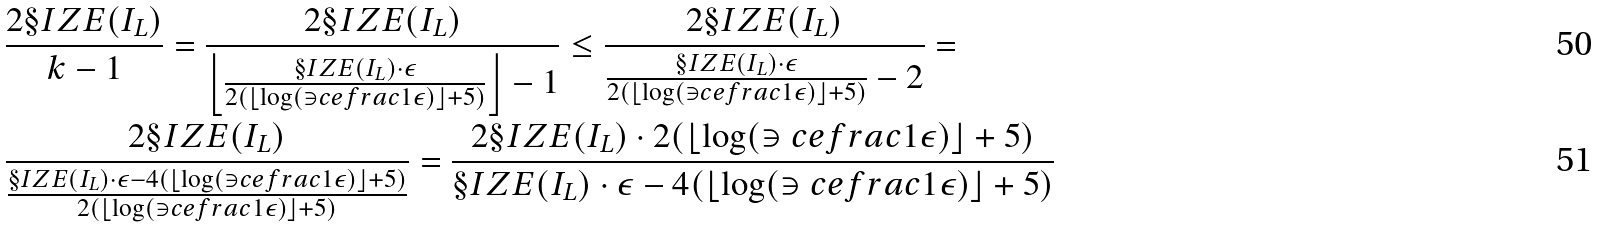Convert formula to latex. <formula><loc_0><loc_0><loc_500><loc_500>& \frac { 2 \S I Z E ( I _ { L } ) } { k - 1 } = \frac { 2 \S I Z E ( I _ { L } ) } { \left \lfloor \frac { \S I Z E ( I _ { L } ) \cdot \epsilon } { 2 ( \lfloor \log ( \ni c e f r a c { 1 } { \epsilon } ) \rfloor + 5 ) } \right \rfloor - 1 } \leq \frac { 2 \S I Z E ( I _ { L } ) } { \frac { \S I Z E ( I _ { L } ) \cdot \epsilon } { 2 ( \lfloor \log ( \ni c e f r a c { 1 } { \epsilon } ) \rfloor + 5 ) } - 2 } = \\ & \frac { 2 \S I Z E ( I _ { L } ) } { \frac { \S I Z E ( I _ { L } ) \cdot \epsilon - 4 ( \lfloor \log ( \ni c e f r a c { 1 } { \epsilon } ) \rfloor + 5 ) } { 2 ( \lfloor \log ( \ni c e f r a c { 1 } { \epsilon } ) \rfloor + 5 ) } } = \frac { 2 \S I Z E ( I _ { L } ) \cdot 2 ( \lfloor \log ( \ni c e f r a c { 1 } { \epsilon } ) \rfloor + 5 ) } { \S I Z E ( I _ { L } ) \cdot \epsilon - 4 ( \lfloor \log ( \ni c e f r a c { 1 } { \epsilon } ) \rfloor + 5 ) }</formula> 